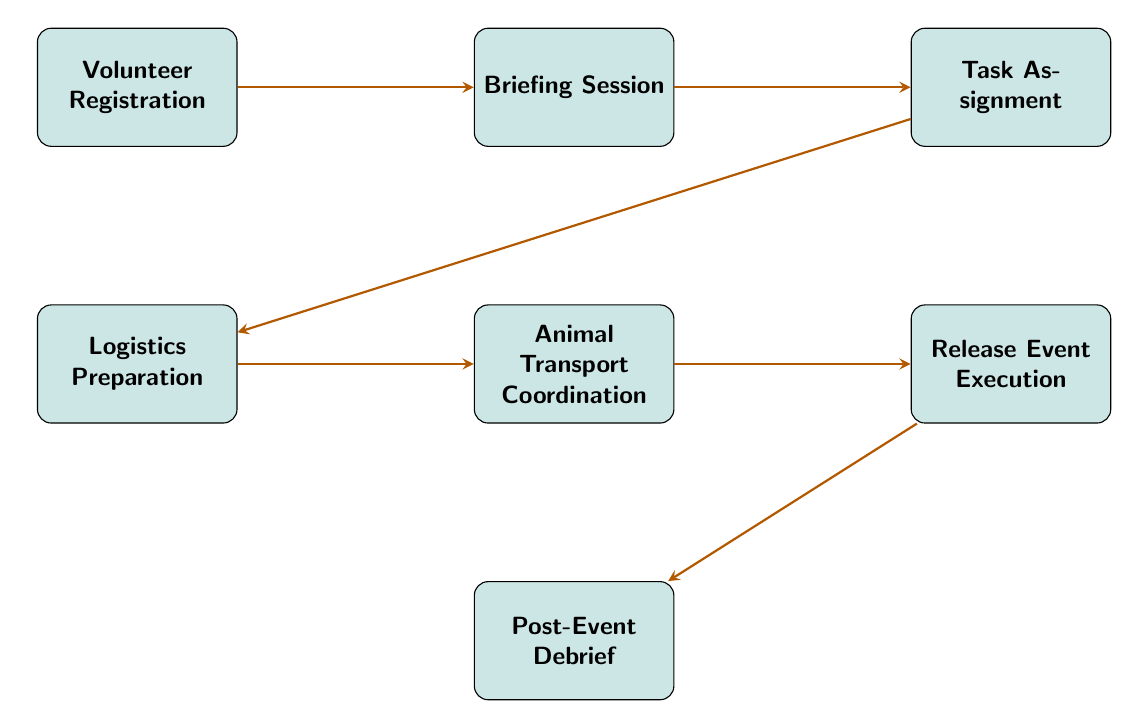What is the first step in the volunteer coordination process? The diagram shows "Volunteer Registration" as the first node. This indicates that the first action is to collect volunteer information and verify their eligibility.
Answer: Volunteer Registration How many nodes are present in the diagram? By counting the distinct steps in the flow chart, there are a total of 7 nodes illustrating different tasks involved in the wildlife release event coordination.
Answer: 7 What does the node 'Animal Transport Coordination' connect to? Examining the connections in the diagram, 'Animal Transport Coordination' (node 5) links directly to 'Release Event Execution' (node 6), indicating that this step is a prerequisite for the actual release.
Answer: Release Event Execution What is the last step in the volunteer coordination process? The final node in the flow chart is 'Post-Event Debrief', which occurs after the 'Release Event Execution', indicating it is the concluding task to gather feedback and document outcomes.
Answer: Post-Event Debrief What precedes the 'Task Assignment' step? The connection diagram shows that 'Briefing Session' (node 2) is directly linked to 'Task Assignment' (node 3), meaning it is the immediate predecessor that provides the information needed for assigning tasks.
Answer: Briefing Session What are the types of activities involved in this flow chart? The nodes highlight various activities, such as registration, briefing, task assignment, logistics preparation, transport coordination, event execution, and post-event debriefing, collectively detailing the coordination process for wildlife rehabilitation.
Answer: Volunteer coordination activities 